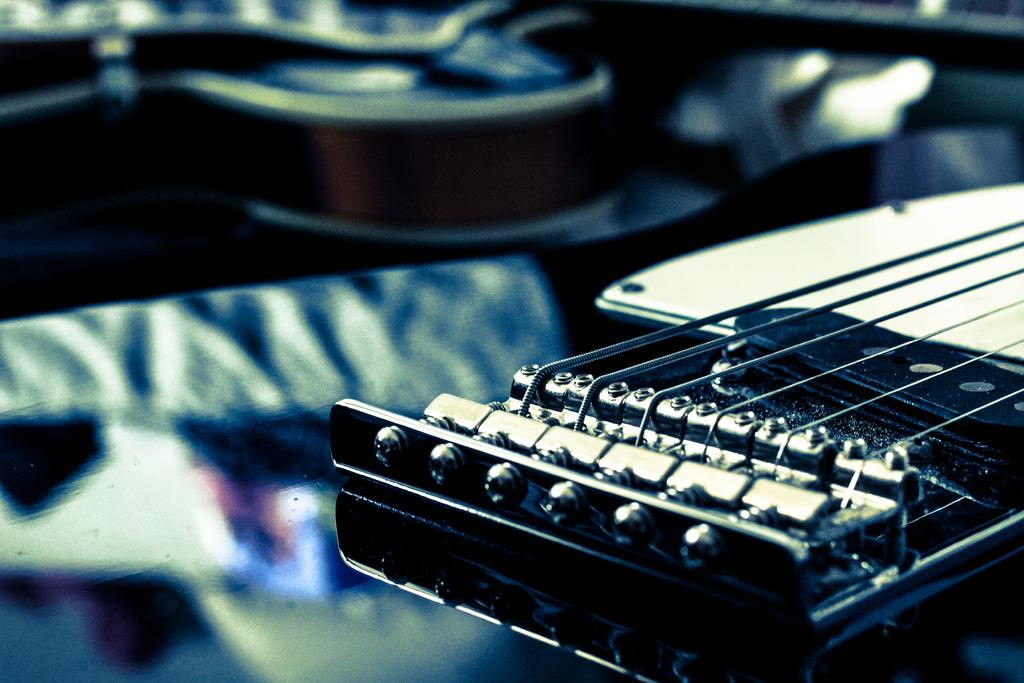What type of musical instrument is in the image? The image contains a musical instrument with strings. Can you describe the strings on the musical instrument? The strings on the musical instrument are visible in the image. How does the musical instrument contribute to the quiet atmosphere in the image? The image does not convey any information about the atmosphere or noise level, so it cannot be determined if the musical instrument contributes to a quiet atmosphere. 